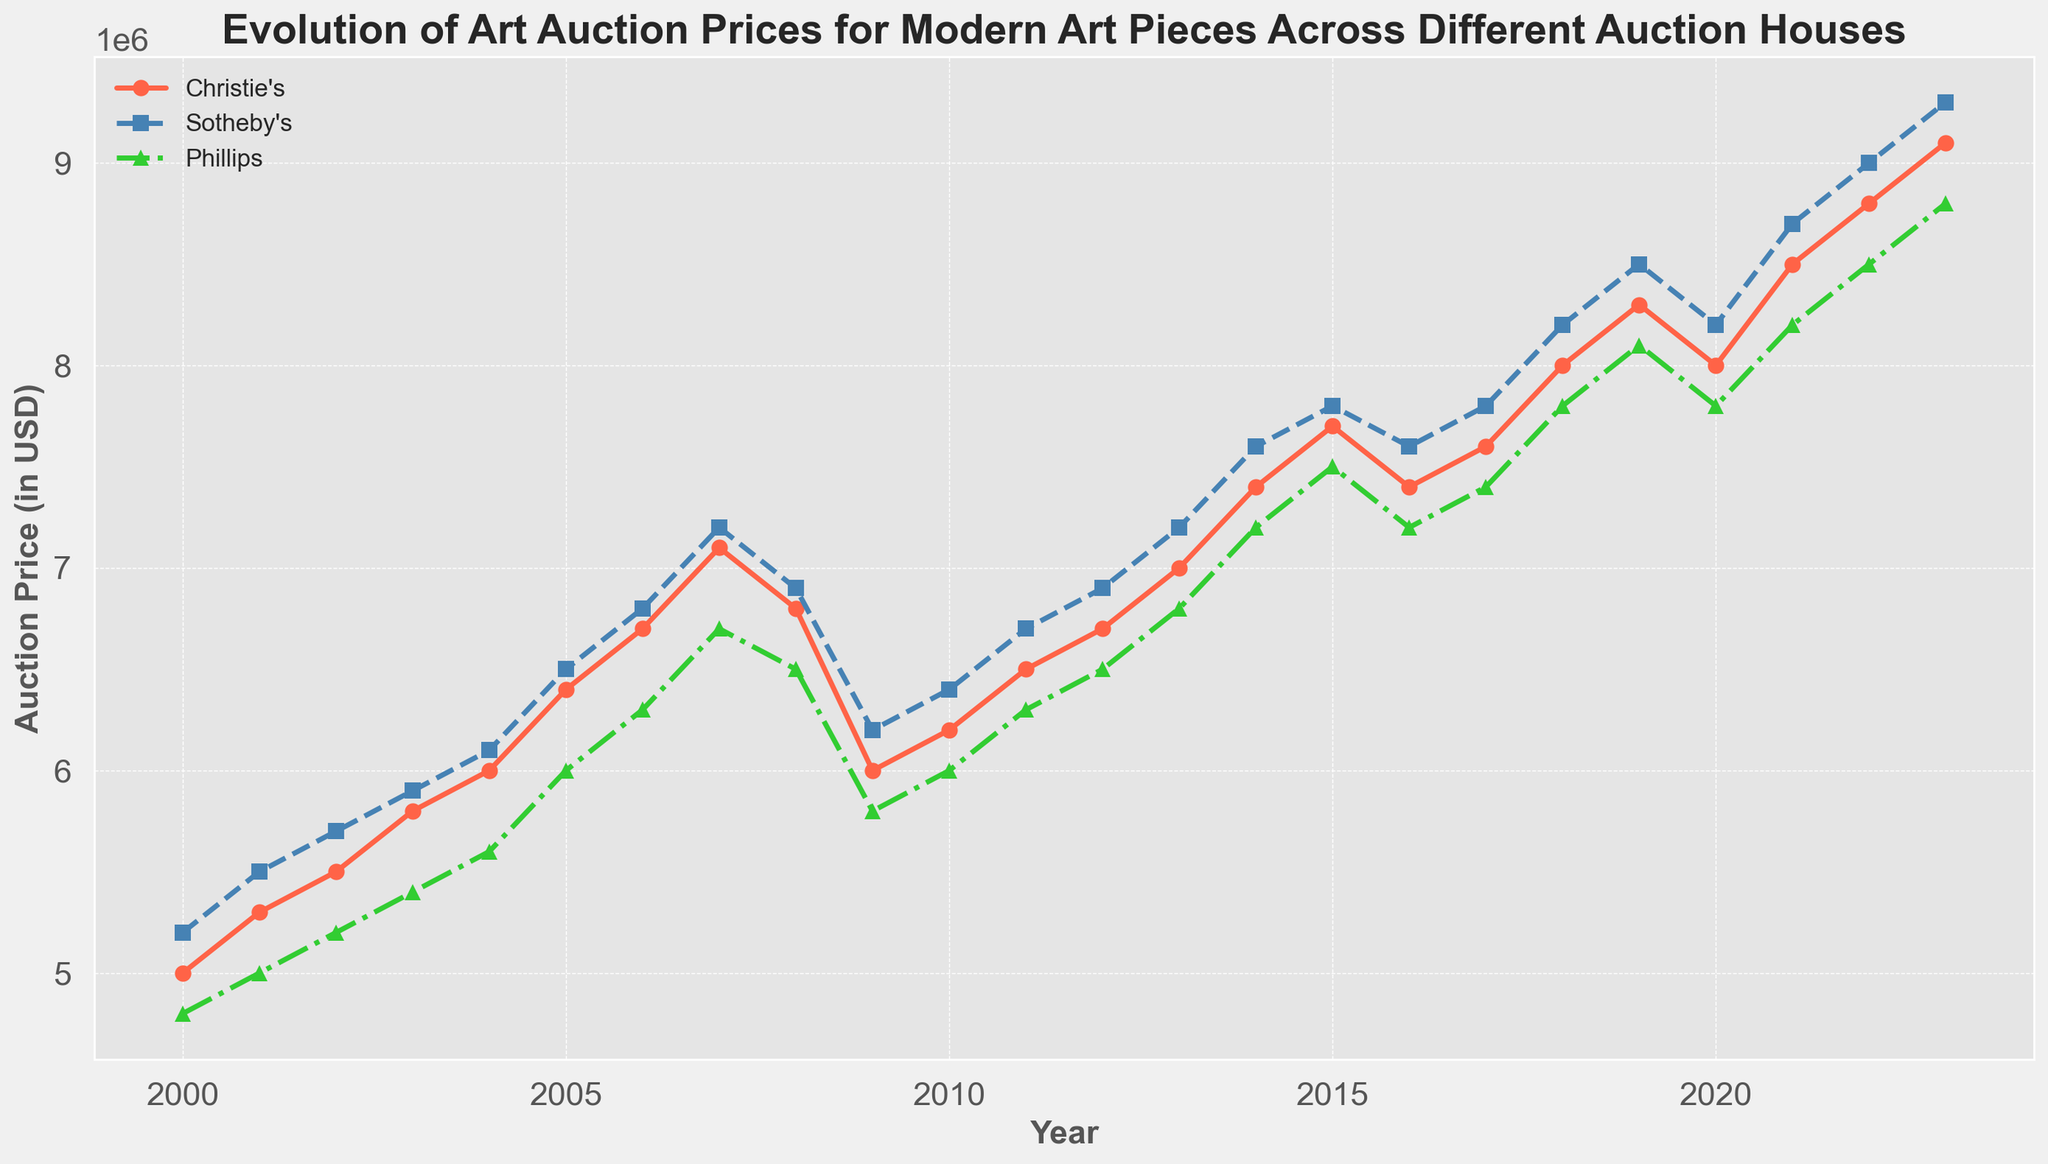Which auction house showed the highest auction price in 2023? To find the highest auction price in 2023, look at the y-values corresponding to the year 2023 for each auction house. Christie's is at $9,100,000, Sotheby's is at $9,300,000, and Phillips is at $8,800,000. The highest value is at Sotheby's.
Answer: Sotheby's During which year did Christie's prices surpass $7,000,000 for the first time? Look at the graph for Christie's and identify the year where the price exceeds $7,000,000 for the first time. This happens in 2013 with a price of $7,000,000.
Answer: 2013 What trend can be observed for Phillips from 2000 to 2023? Observe the plot line for Phillips auction house from 2000 to 2023. The prices started around $4,800,000 in 2000, exhibited an overall upward trend with a slight dip around 2008 and 2009, but generally increasing to $8,800,000 in 2023.
Answer: Upward trend with a slight dip around 2008-2009 Compare the auction prices of Sotheby's and Christie's in 2010. Which was higher and by how much? Find the point values for both Sotheby's and Christie's in the year 2010. Sotheby's had $6,400,000 and Christie's had $6,200,000. The difference is $6,400,000 - $6,200,000 = $200,000.
Answer: Sotheby's by $200,000 What general pattern do the auction prices exhibit during 2008-2009 for all the auction houses? Examine the prices for 2008 and 2009 across the three auction houses. All three show a peak in 2007, a drop in 2008, and a further drop or stagnation in 2009, indicating a dip in prices, correlating with the global financial crisis.
Answer: Dip in prices What is the average auction price for Christie's between 2010 and 2020? Calculate the average for Christie's auction prices from 2010 to 2020. Sum the values and divide by the number of years:
(6,200,000 + 6,500,000 + 6,700,000 + 7,000,000 + 7,400,000 + 7,700,000 + 7,400,000 + 7,600,000 + 8,000,000 + 8,300,000 + 8,000,000) / 11 = $7,418,182 approximately.
Answer: $7,418,182 approximately Which auction house experienced the most significant price increase between 2005 and 2007? Calculate the price difference for each auction house between 2005 and 2007: 
Christie's: $7,100,000 - $6,400,000 = $700,000; 
Sotheby's: $7,200,000 - $6,500,000 = $700,000; 
Phillips: $6,700,000 - $6,000,000 = $700,000. 
All experienced the same increase of $700,000.
Answer: All experienced the same increase of $700,000 How did the prices at Sotheby's change from 2015 to 2016? Look at the prices for Sotheby's in 2015 and 2016. In 2015, the price was $7,800,000, and in 2016 it was $7,600,000. The price decreased by $200,000.
Answer: Decreased by $200,000 Identify the years during which all three auction houses had a price at least $7,000,000. Examine the chart and find the periods when all three lines were above the $7,000,000 mark. This occurs from 2013 onwards.
Answer: 2013 onwards 